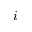<formula> <loc_0><loc_0><loc_500><loc_500>i</formula> 